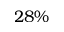<formula> <loc_0><loc_0><loc_500><loc_500>2 8 \%</formula> 